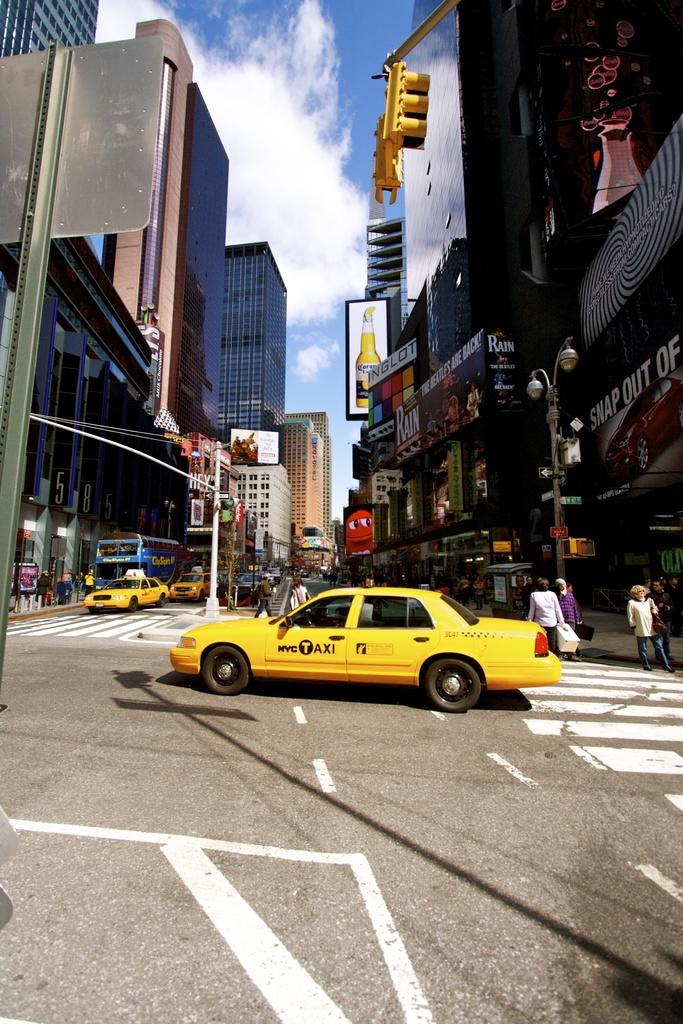<image>
Offer a succinct explanation of the picture presented. A NYC taxi us driving through an intersection 